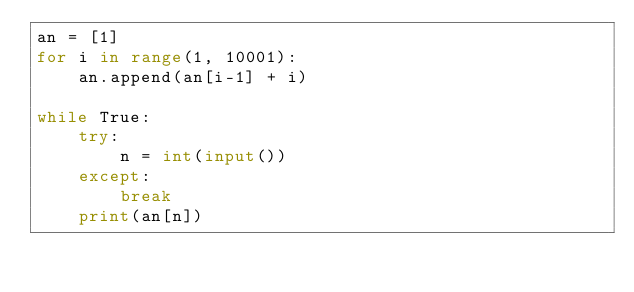<code> <loc_0><loc_0><loc_500><loc_500><_Python_>an = [1]
for i in range(1, 10001):
    an.append(an[i-1] + i)

while True:
    try:
        n = int(input())
    except:
        break
    print(an[n])
</code> 